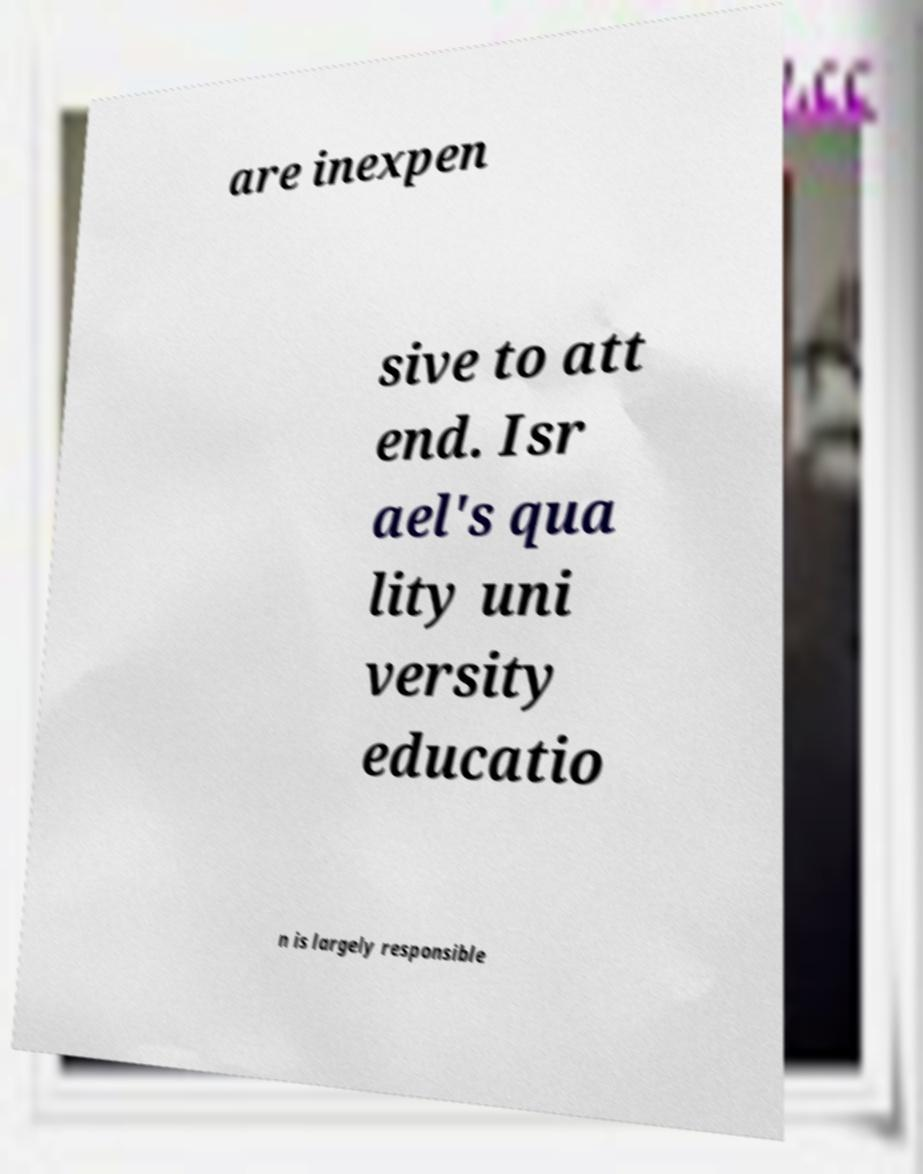Please identify and transcribe the text found in this image. are inexpen sive to att end. Isr ael's qua lity uni versity educatio n is largely responsible 